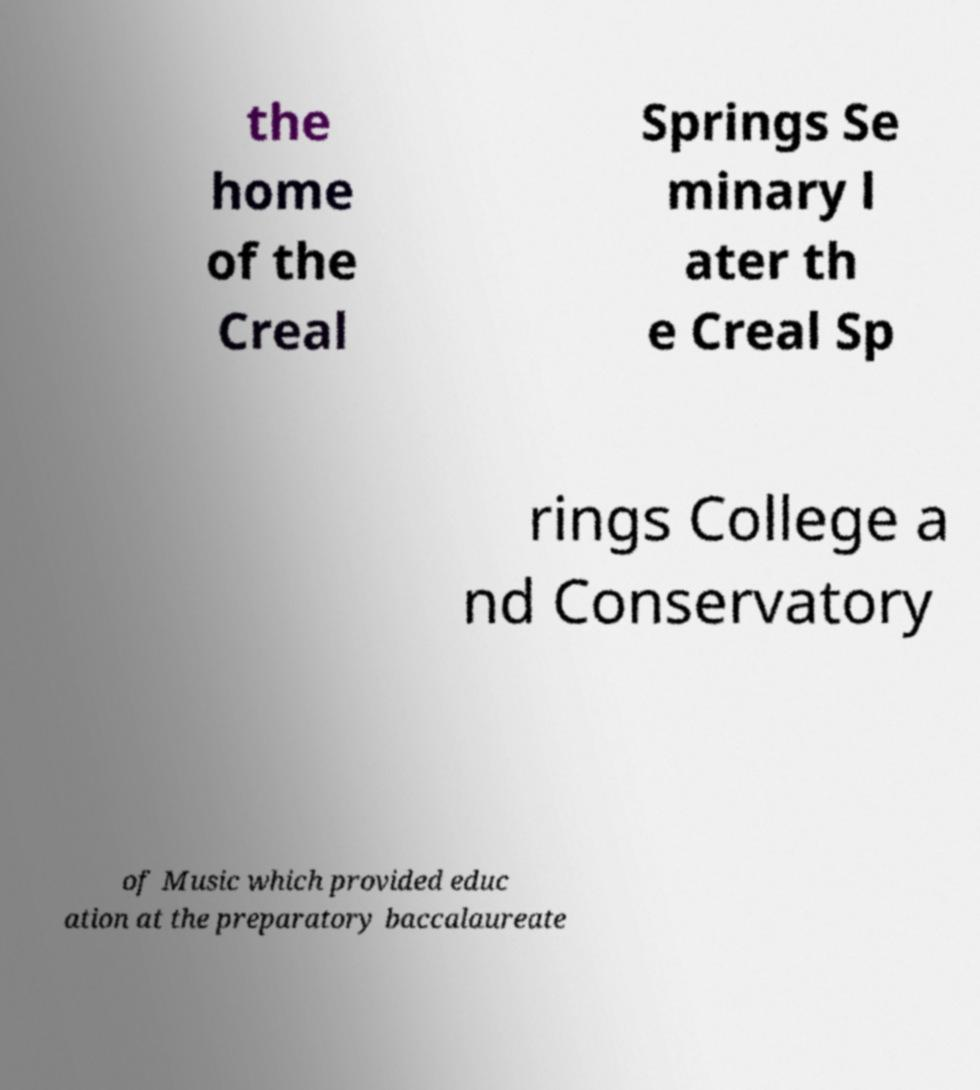Could you extract and type out the text from this image? the home of the Creal Springs Se minary l ater th e Creal Sp rings College a nd Conservatory of Music which provided educ ation at the preparatory baccalaureate 